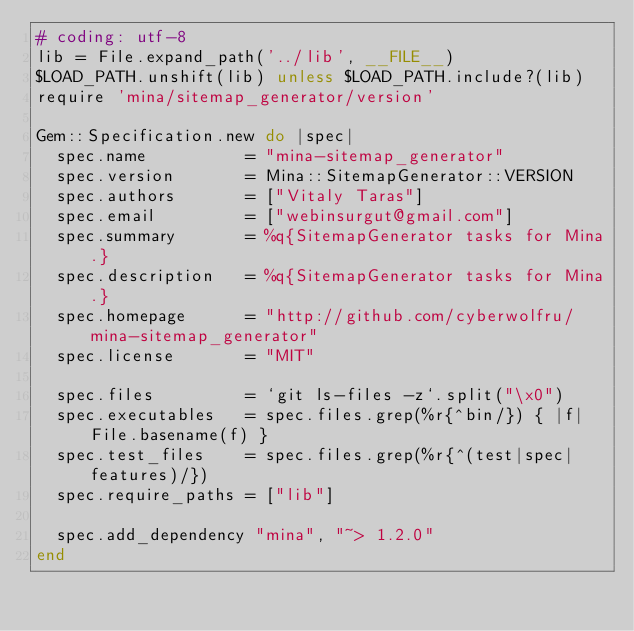<code> <loc_0><loc_0><loc_500><loc_500><_Ruby_># coding: utf-8
lib = File.expand_path('../lib', __FILE__)
$LOAD_PATH.unshift(lib) unless $LOAD_PATH.include?(lib)
require 'mina/sitemap_generator/version'

Gem::Specification.new do |spec|
  spec.name          = "mina-sitemap_generator"
  spec.version       = Mina::SitemapGenerator::VERSION
  spec.authors       = ["Vitaly Taras"]
  spec.email         = ["webinsurgut@gmail.com"]
  spec.summary       = %q{SitemapGenerator tasks for Mina.}
  spec.description   = %q{SitemapGenerator tasks for Mina.}
  spec.homepage      = "http://github.com/cyberwolfru/mina-sitemap_generator"
  spec.license       = "MIT"

  spec.files         = `git ls-files -z`.split("\x0")
  spec.executables   = spec.files.grep(%r{^bin/}) { |f| File.basename(f) }
  spec.test_files    = spec.files.grep(%r{^(test|spec|features)/})
  spec.require_paths = ["lib"]

  spec.add_dependency "mina", "~> 1.2.0"
end
</code> 